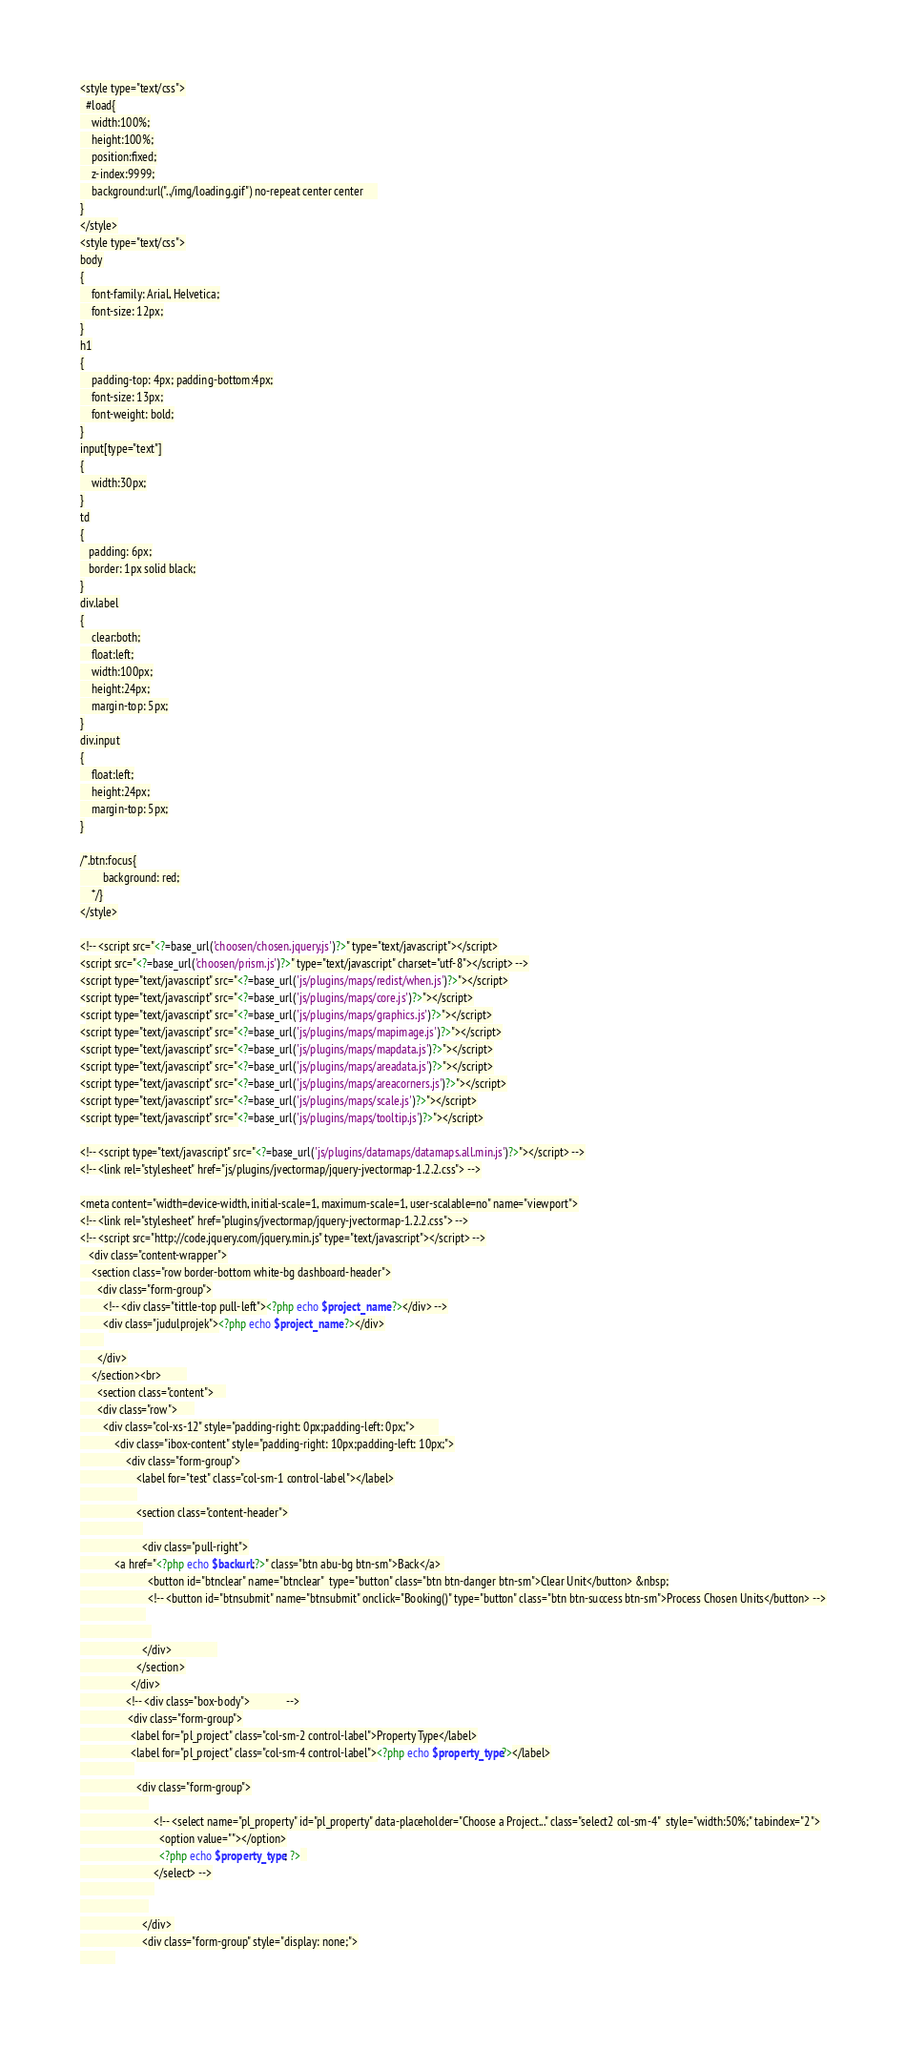<code> <loc_0><loc_0><loc_500><loc_500><_PHP_>
<style type="text/css">
  #load{
    width:100%;
    height:100%;
    position:fixed;
    z-index:9999;
    background:url("../img/loading.gif") no-repeat center center     
}
</style>
<style type="text/css">
body
{
    font-family: Arial, Helvetica;
    font-size: 12px;
}
h1
{
    padding-top: 4px; padding-bottom:4px;
    font-size: 13px;
    font-weight: bold;
}
input[type="text"]
{
    width:30px;
}
td
{
   padding: 6px;
   border: 1px solid black;
}
div.label
{
    clear:both;
    float:left;
    width:100px;
    height:24px;
    margin-top: 5px;
}
div.input
{
    float:left;
    height:24px;
    margin-top: 5px;
}

/*.btn:focus{
        background: red;
    */}
</style>

<!-- <script src="<?=base_url('choosen/chosen.jquery.js')?>" type="text/javascript"></script>
<script src="<?=base_url('choosen/prism.js')?>" type="text/javascript" charset="utf-8"></script> -->
<script type="text/javascript" src="<?=base_url('js/plugins/maps/redist/when.js')?>"></script>
<script type="text/javascript" src="<?=base_url('js/plugins/maps/core.js')?>"></script>
<script type="text/javascript" src="<?=base_url('js/plugins/maps/graphics.js')?>"></script>
<script type="text/javascript" src="<?=base_url('js/plugins/maps/mapimage.js')?>"></script>
<script type="text/javascript" src="<?=base_url('js/plugins/maps/mapdata.js')?>"></script>
<script type="text/javascript" src="<?=base_url('js/plugins/maps/areadata.js')?>"></script>
<script type="text/javascript" src="<?=base_url('js/plugins/maps/areacorners.js')?>"></script>
<script type="text/javascript" src="<?=base_url('js/plugins/maps/scale.js')?>"></script>
<script type="text/javascript" src="<?=base_url('js/plugins/maps/tooltip.js')?>"></script>

<!-- <script type="text/javascript" src="<?=base_url('js/plugins/datamaps/datamaps.all.min.js')?>"></script> -->
<!-- <link rel="stylesheet" href="js/plugins/jvectormap/jquery-jvectormap-1.2.2.css"> -->

<meta content="width=device-width, initial-scale=1, maximum-scale=1, user-scalable=no" name="viewport">
<!-- <link rel="stylesheet" href="plugins/jvectormap/jquery-jvectormap-1.2.2.css"> -->
<!-- <script src="http://code.jquery.com/jquery.min.js" type="text/javascript"></script> -->
   <div class="content-wrapper">
    <section class="row border-bottom white-bg dashboard-header">
      <div class="form-group">
        <!-- <div class="tittle-top pull-left"><?php echo $project_name ?></div> -->
        <div class="judulprojek"><?php echo $project_name ?></div>
        
      </div>
    </section><br>         
      <section class="content">    
      <div class="row">      
        <div class="col-xs-12" style="padding-right: 0px;padding-left: 0px;">        
            <div class="ibox-content" style="padding-right: 10px;padding-left: 10px;">
				<div class="form-group">
					<label for="test" class="col-sm-1 control-label"></label>
					
					<section class="content-header">
					  
					  <div class="pull-right">
            <a href="<?php echo $backurl;?>" class="btn abu-bg btn-sm">Back</a> 
						<button id="btnclear" name="btnclear"  type="button" class="btn btn-danger btn-sm">Clear Unit</button> &nbsp;
						<!-- <button id="btnsubmit" name="btnsubmit" onclick="Booking()" type="button" class="btn btn-success btn-sm">Process Chosen Units</button> -->
					   
						 
					  </div>                
					</section>
				  </div>
				<!-- <div class="box-body">             -->
				 <div class="form-group">
				  <label for="pl_project" class="col-sm-2 control-label">Property Type</label>
                  <label for="pl_project" class="col-sm-4 control-label"><?php echo $property_type?></label>
				   
					<div class="form-group">
						
						  <!-- <select name="pl_property" id="pl_property" data-placeholder="Choose a Project..." class="select2 col-sm-4"  style="width:50%;" tabindex="2">
							<option value=""></option>
							<?php echo $property_type; ?>  
						  </select> -->
						  
						
					  </div> 
					  <div class="form-group" style="display: none;">
            </code> 